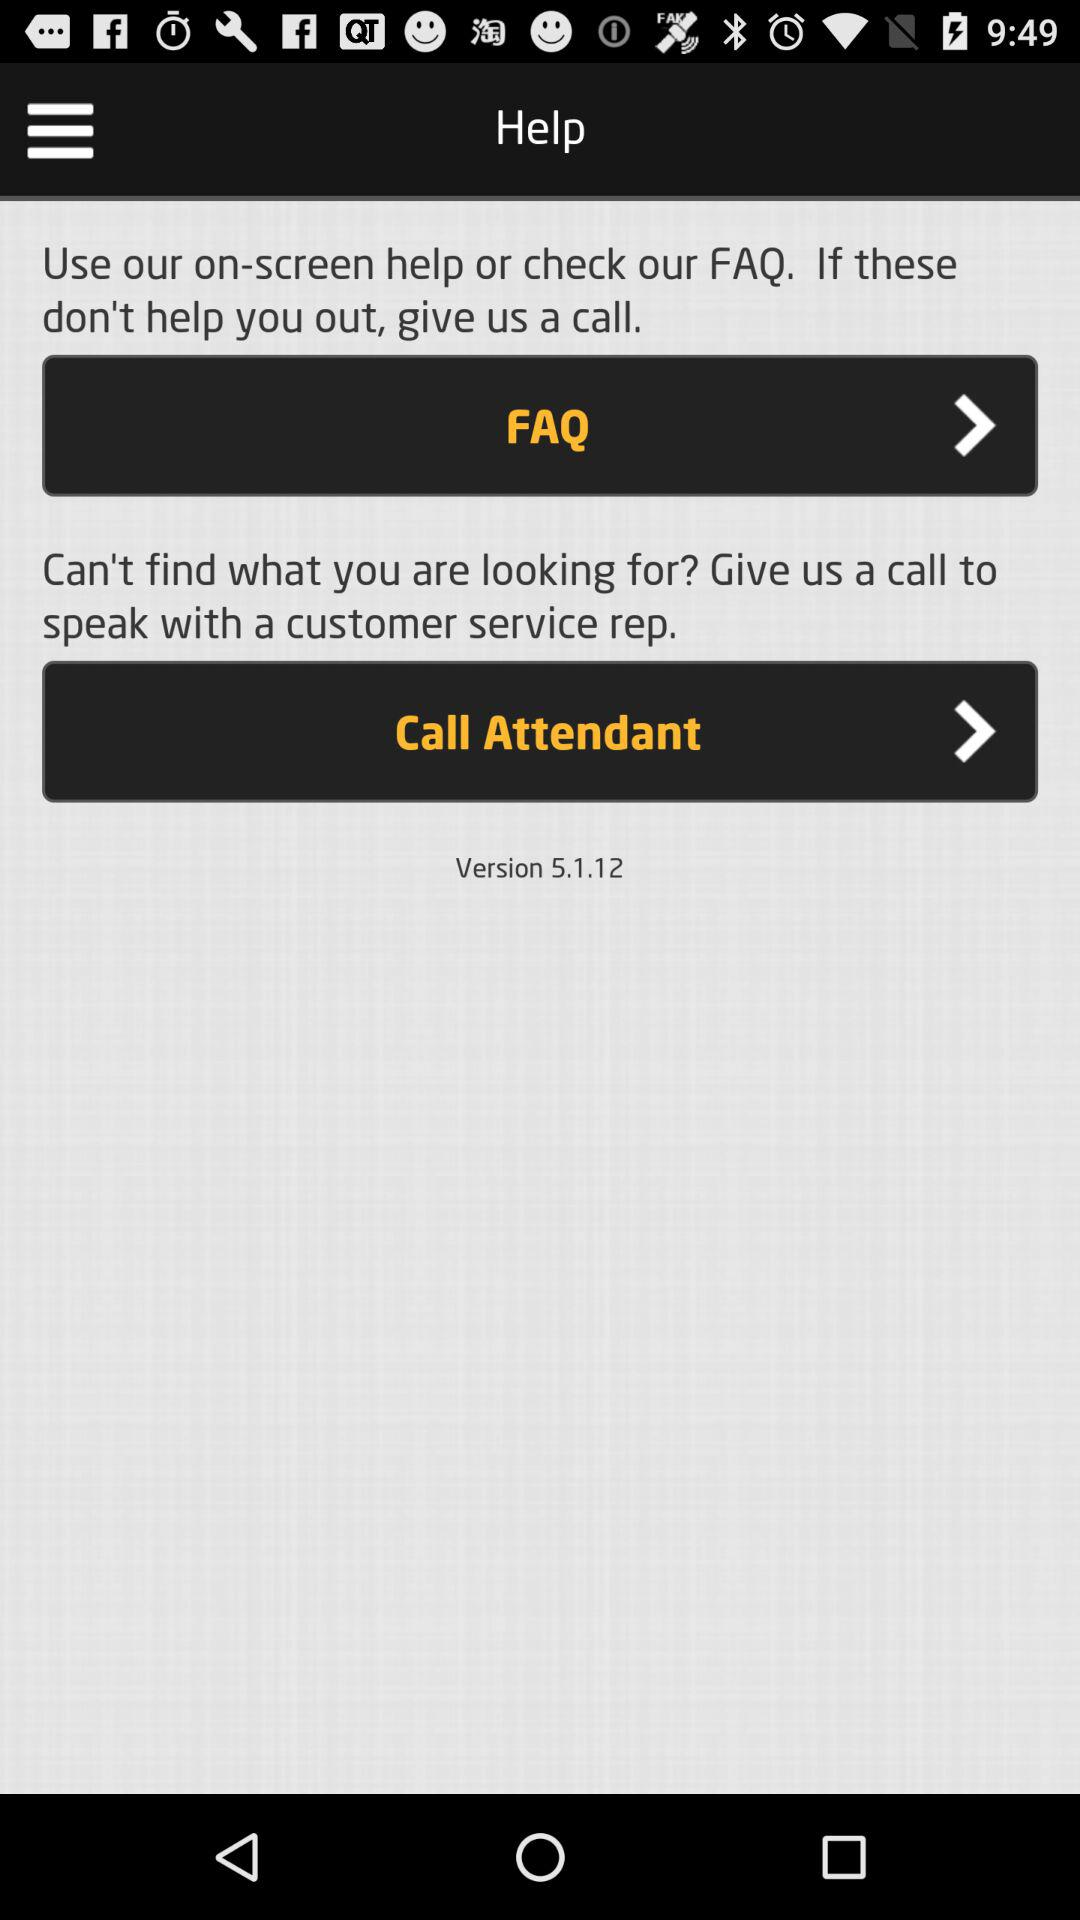What is the given version? The given version is 5.1.12. 